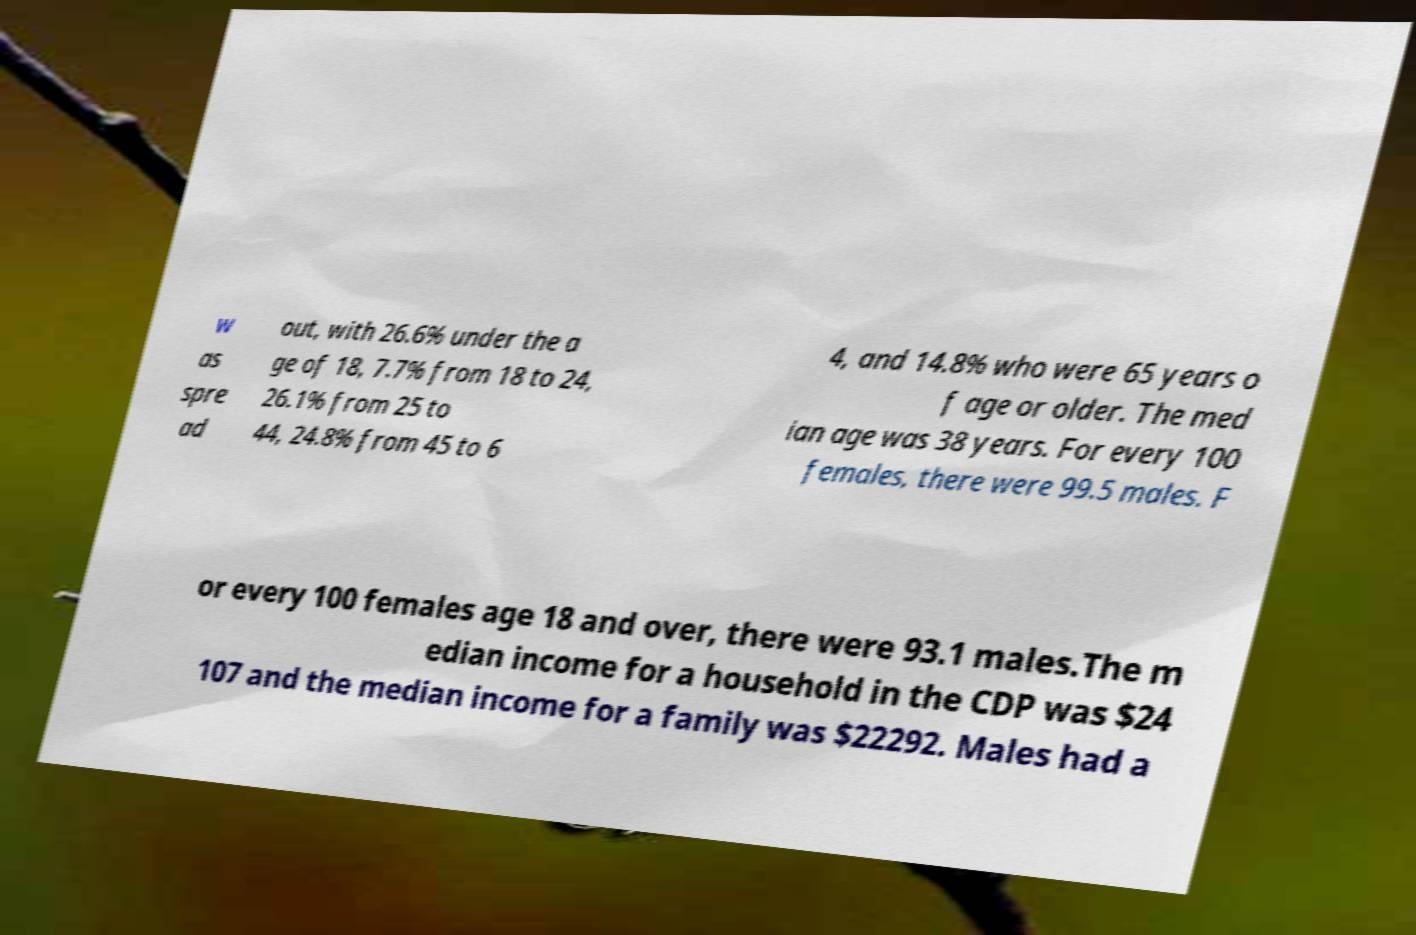Could you assist in decoding the text presented in this image and type it out clearly? w as spre ad out, with 26.6% under the a ge of 18, 7.7% from 18 to 24, 26.1% from 25 to 44, 24.8% from 45 to 6 4, and 14.8% who were 65 years o f age or older. The med ian age was 38 years. For every 100 females, there were 99.5 males. F or every 100 females age 18 and over, there were 93.1 males.The m edian income for a household in the CDP was $24 107 and the median income for a family was $22292. Males had a 